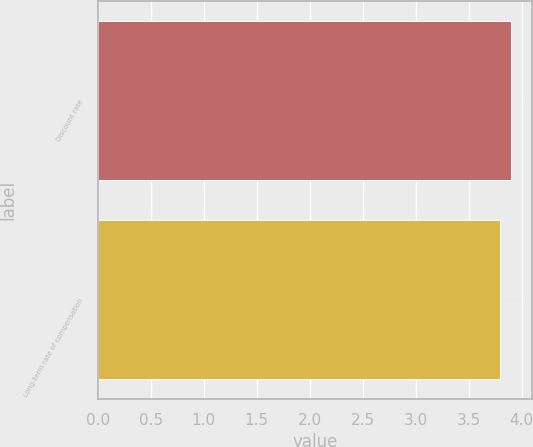Convert chart to OTSL. <chart><loc_0><loc_0><loc_500><loc_500><bar_chart><fcel>Discount rate<fcel>Long-term rate of compensation<nl><fcel>3.9<fcel>3.8<nl></chart> 